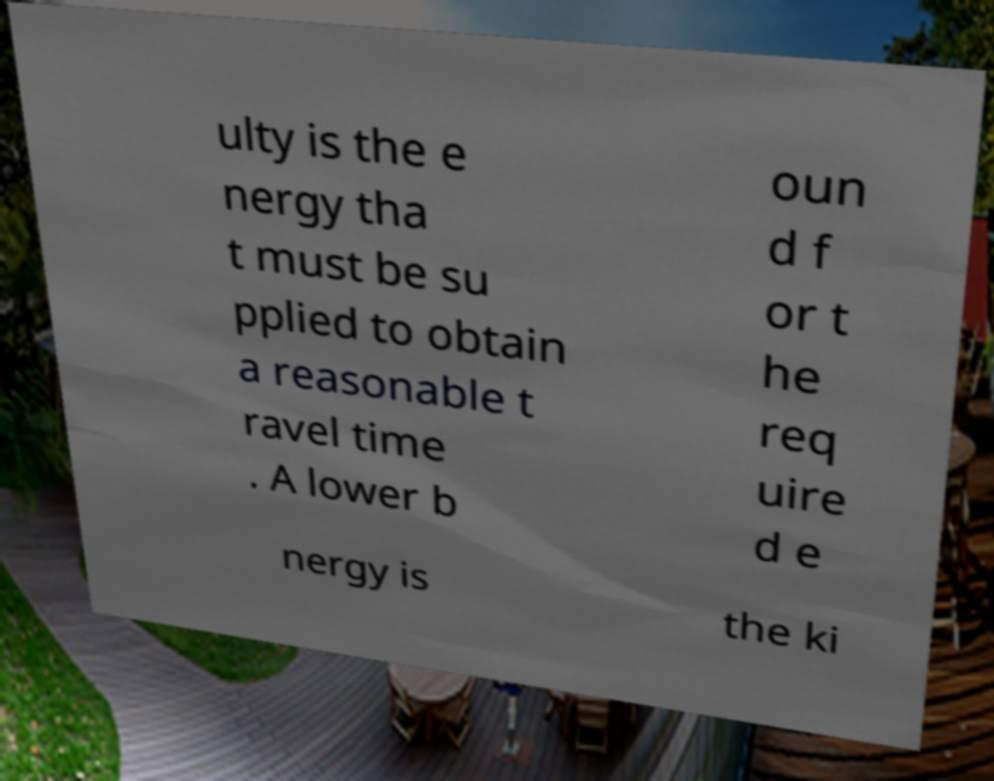Could you assist in decoding the text presented in this image and type it out clearly? ulty is the e nergy tha t must be su pplied to obtain a reasonable t ravel time . A lower b oun d f or t he req uire d e nergy is the ki 